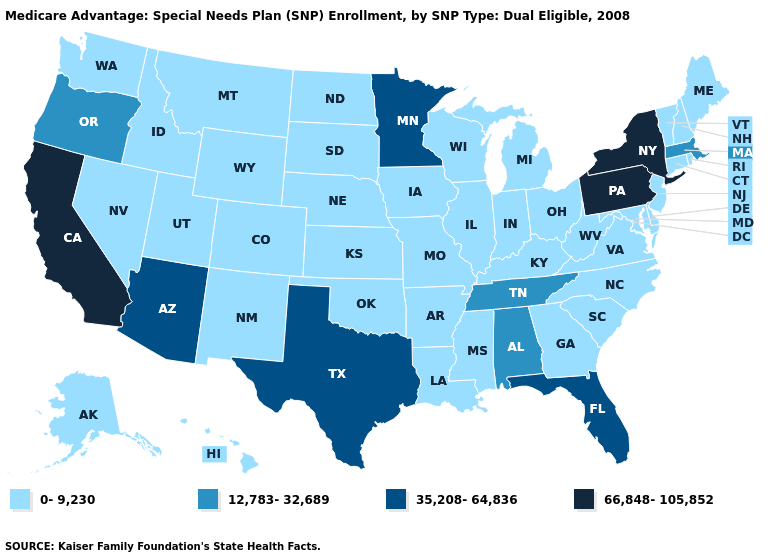What is the value of Ohio?
Write a very short answer. 0-9,230. Name the states that have a value in the range 35,208-64,836?
Write a very short answer. Arizona, Florida, Minnesota, Texas. Among the states that border Rhode Island , which have the highest value?
Answer briefly. Massachusetts. Is the legend a continuous bar?
Answer briefly. No. Is the legend a continuous bar?
Quick response, please. No. Does Minnesota have the highest value in the MidWest?
Quick response, please. Yes. Among the states that border Oklahoma , which have the lowest value?
Short answer required. Arkansas, Colorado, Kansas, Missouri, New Mexico. Is the legend a continuous bar?
Concise answer only. No. What is the value of Iowa?
Give a very brief answer. 0-9,230. Which states have the highest value in the USA?
Answer briefly. California, New York, Pennsylvania. What is the value of Illinois?
Keep it brief. 0-9,230. What is the value of Ohio?
Give a very brief answer. 0-9,230. Among the states that border Montana , which have the lowest value?
Quick response, please. Idaho, North Dakota, South Dakota, Wyoming. Name the states that have a value in the range 66,848-105,852?
Be succinct. California, New York, Pennsylvania. What is the value of Michigan?
Give a very brief answer. 0-9,230. 